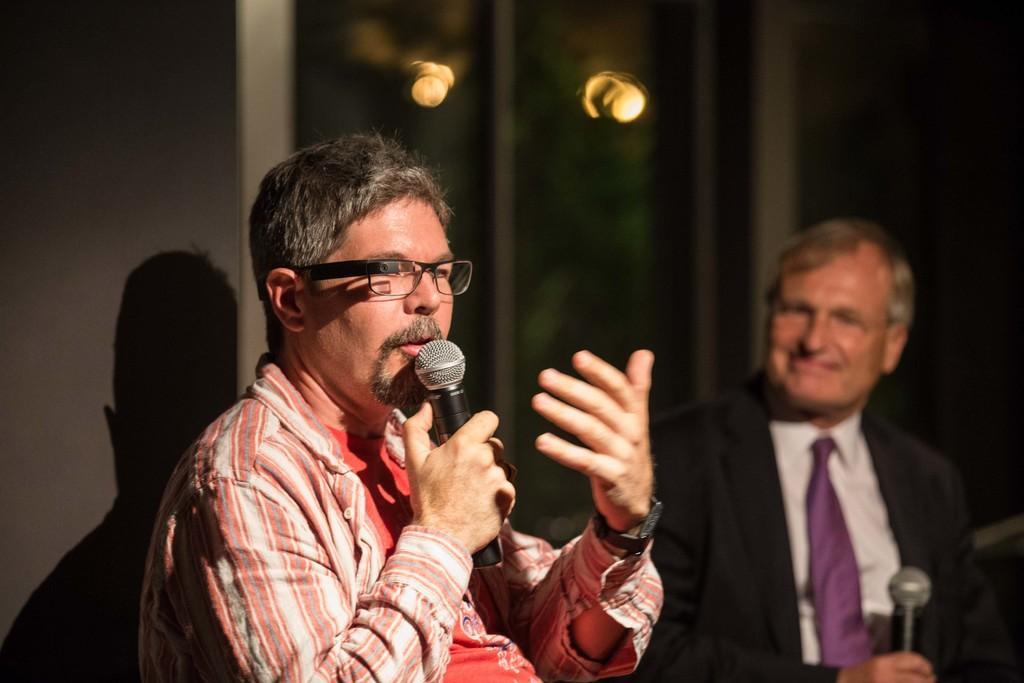How would you summarize this image in a sentence or two? This picture is clicked inside the room. The man in the front of the picture wearing red t-shirt is holding microphone in his hand and he is talking on it. He is even wearing spectacles and watch. Behind her, we see a man in white shirt is wearing black blazer and purple color tie is also holding microphone in his hands and he is smiling. Behind them, we see wall and also two lights. 